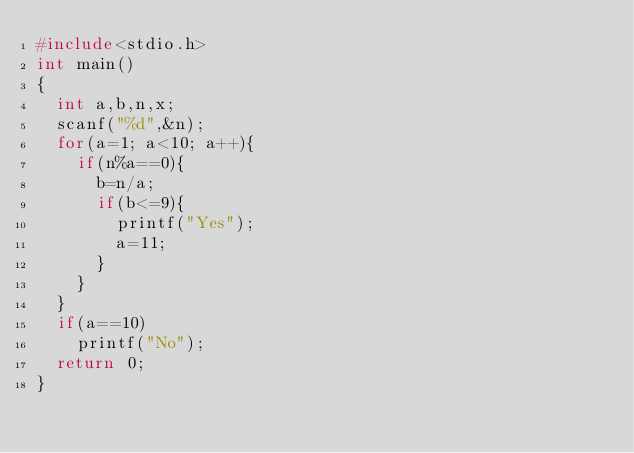<code> <loc_0><loc_0><loc_500><loc_500><_C_>#include<stdio.h>
int main()
{
  int a,b,n,x;
  scanf("%d",&n);
  for(a=1; a<10; a++){
    if(n%a==0){
      b=n/a;
      if(b<=9){
        printf("Yes");
        a=11;
      }
    }
  }
  if(a==10)
    printf("No");
  return 0;
}</code> 